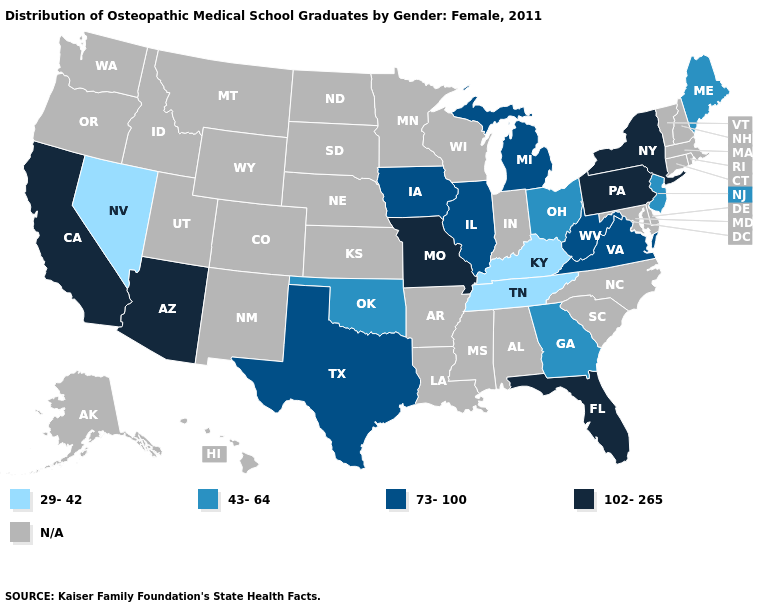What is the value of Michigan?
Short answer required. 73-100. Among the states that border Missouri , which have the highest value?
Short answer required. Illinois, Iowa. Does the first symbol in the legend represent the smallest category?
Answer briefly. Yes. Among the states that border Kansas , which have the lowest value?
Answer briefly. Oklahoma. Which states have the lowest value in the USA?
Give a very brief answer. Kentucky, Nevada, Tennessee. Does the map have missing data?
Concise answer only. Yes. What is the value of Wisconsin?
Answer briefly. N/A. What is the lowest value in states that border Oklahoma?
Give a very brief answer. 73-100. Among the states that border Ohio , does Kentucky have the highest value?
Write a very short answer. No. What is the highest value in the West ?
Quick response, please. 102-265. Does the map have missing data?
Write a very short answer. Yes. What is the lowest value in the MidWest?
Quick response, please. 43-64. What is the value of Kansas?
Short answer required. N/A. Is the legend a continuous bar?
Give a very brief answer. No. 